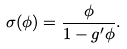Convert formula to latex. <formula><loc_0><loc_0><loc_500><loc_500>\sigma ( \phi ) = \frac { \phi } { 1 - g ^ { \prime } \phi } .</formula> 